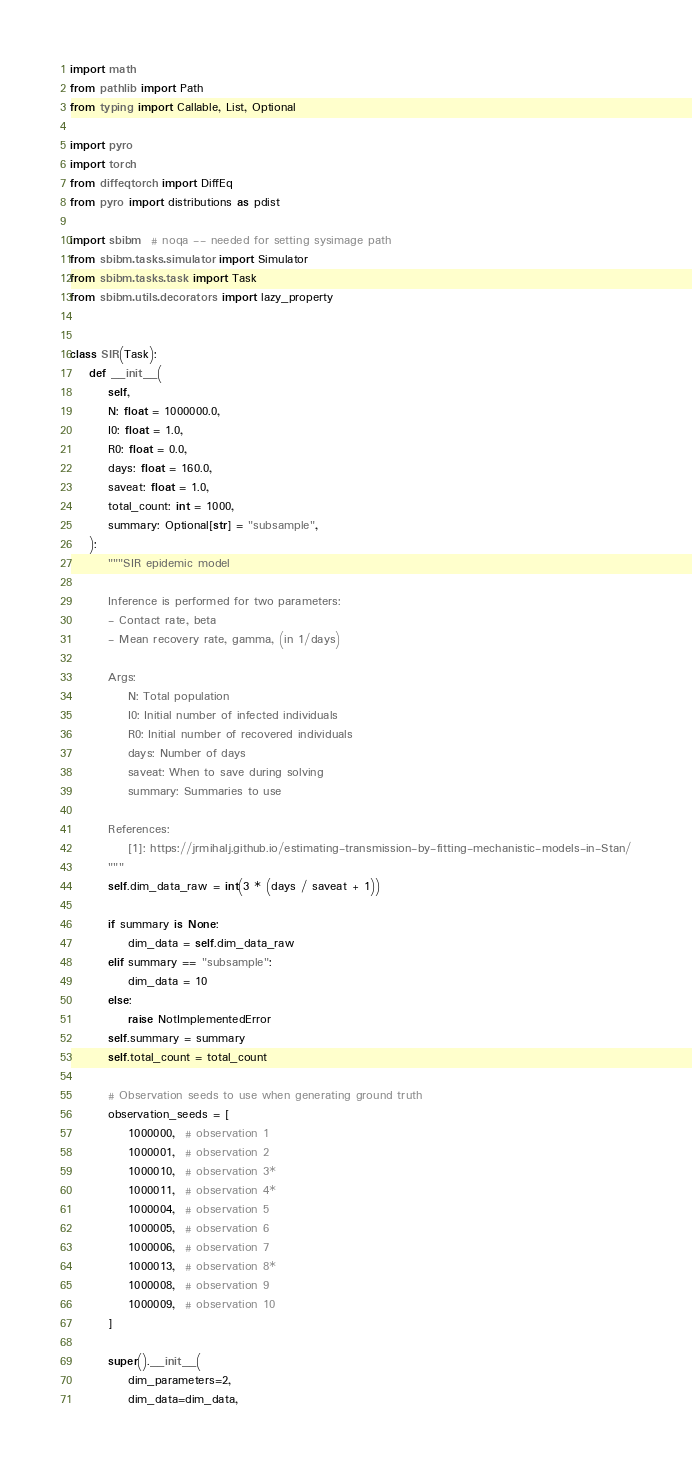Convert code to text. <code><loc_0><loc_0><loc_500><loc_500><_Python_>import math
from pathlib import Path
from typing import Callable, List, Optional

import pyro
import torch
from diffeqtorch import DiffEq
from pyro import distributions as pdist

import sbibm  # noqa -- needed for setting sysimage path
from sbibm.tasks.simulator import Simulator
from sbibm.tasks.task import Task
from sbibm.utils.decorators import lazy_property


class SIR(Task):
    def __init__(
        self,
        N: float = 1000000.0,
        I0: float = 1.0,
        R0: float = 0.0,
        days: float = 160.0,
        saveat: float = 1.0,
        total_count: int = 1000,
        summary: Optional[str] = "subsample",
    ):
        """SIR epidemic model

        Inference is performed for two parameters:
        - Contact rate, beta
        - Mean recovery rate, gamma, (in 1/days)

        Args:
            N: Total population
            I0: Initial number of infected individuals
            R0: Initial number of recovered individuals
            days: Number of days
            saveat: When to save during solving
            summary: Summaries to use

        References:
            [1]: https://jrmihalj.github.io/estimating-transmission-by-fitting-mechanistic-models-in-Stan/
        """
        self.dim_data_raw = int(3 * (days / saveat + 1))

        if summary is None:
            dim_data = self.dim_data_raw
        elif summary == "subsample":
            dim_data = 10
        else:
            raise NotImplementedError
        self.summary = summary
        self.total_count = total_count

        # Observation seeds to use when generating ground truth
        observation_seeds = [
            1000000,  # observation 1
            1000001,  # observation 2
            1000010,  # observation 3*
            1000011,  # observation 4*
            1000004,  # observation 5
            1000005,  # observation 6
            1000006,  # observation 7
            1000013,  # observation 8*
            1000008,  # observation 9
            1000009,  # observation 10
        ]

        super().__init__(
            dim_parameters=2,
            dim_data=dim_data,</code> 